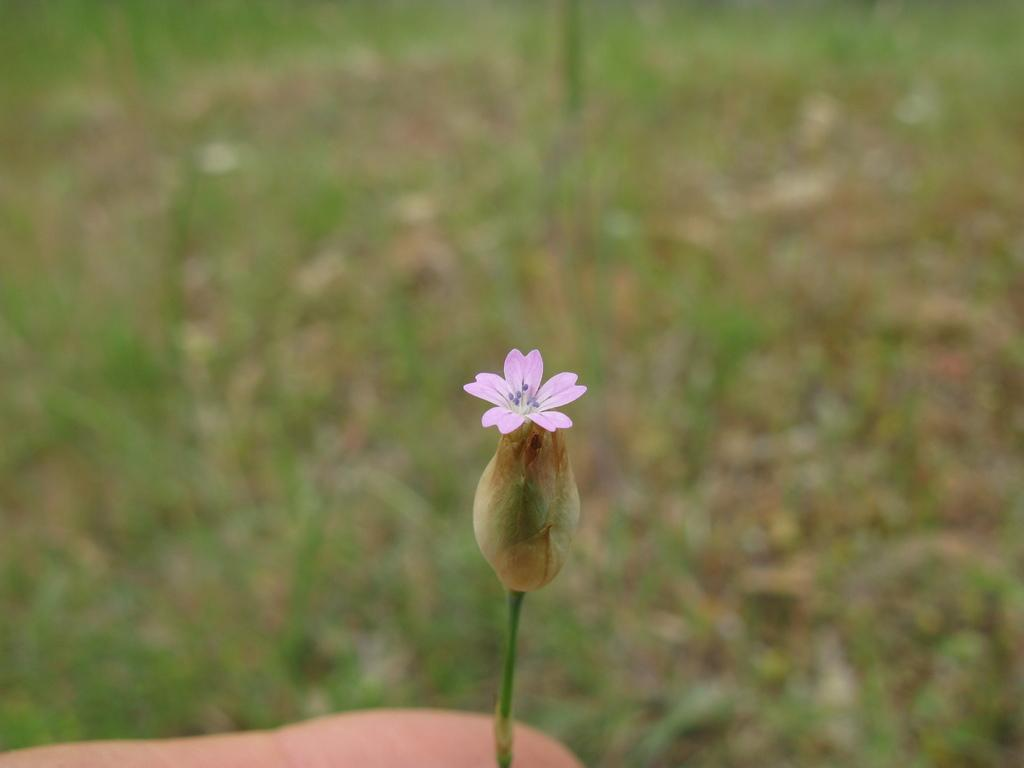What type of flower is in the image? There is a purple flower in the image. What color is the background of the image? The background is green. How is the background of the image depicted? The background is blurred. What type of art activity is being performed in the image? There is no art activity present in the image; it only features a purple flower and a blurred green background. 